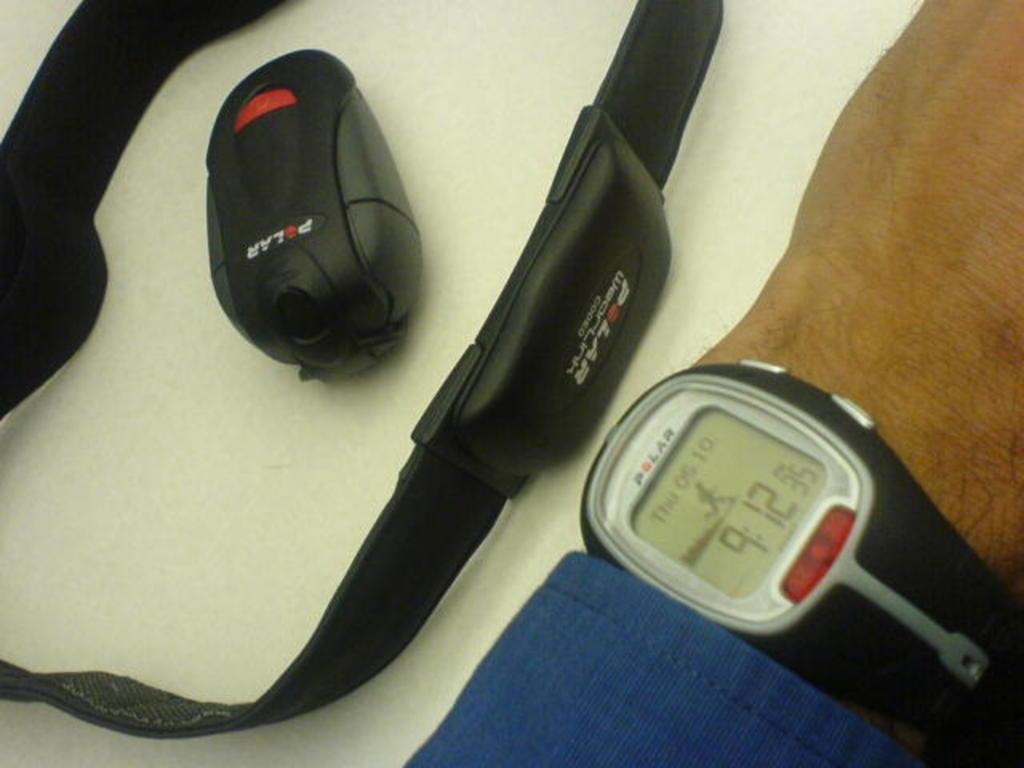What part of the human body is visible in the image? There is a human hand in the image. What accessory is worn on the hand? There is a wrist watch visible on the hand. What type of clothing item is present in the image? There is a belt in the image. What electronic device can be seen on the table? There appears to be a wireless mouse on the table. What type of grape is being used to power the wireless mouse in the image? There is no grape present in the image, and the wireless mouse is not powered by a grape. 